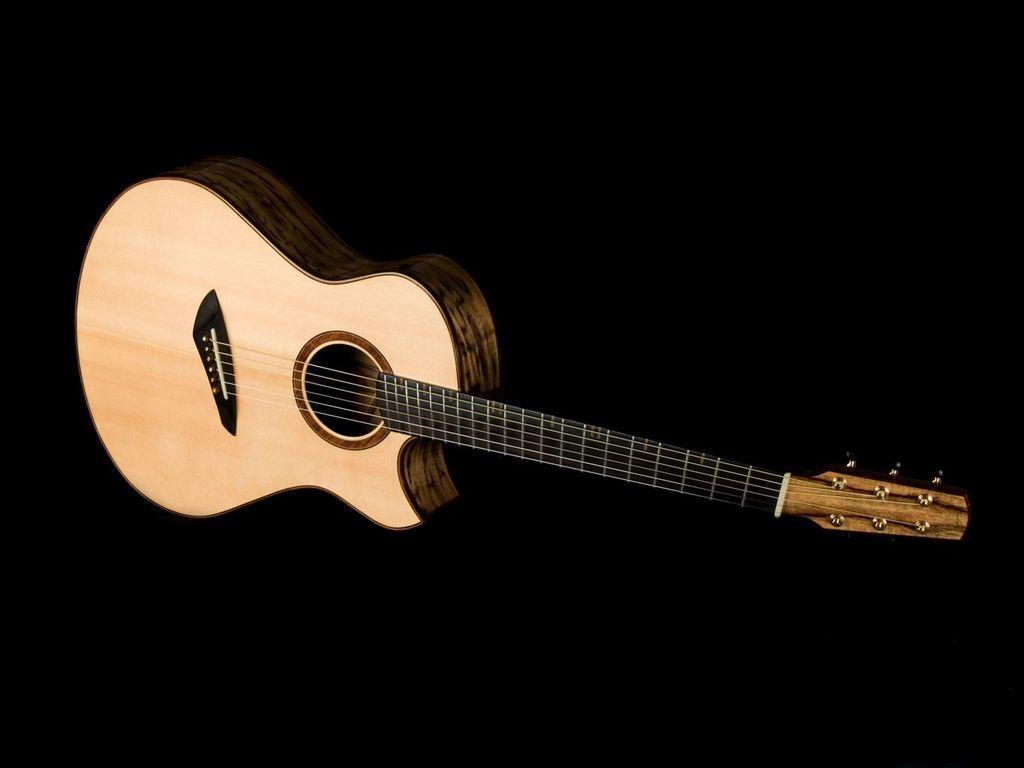Please provide a concise description of this image. In the middle of the image there is a guitar. 